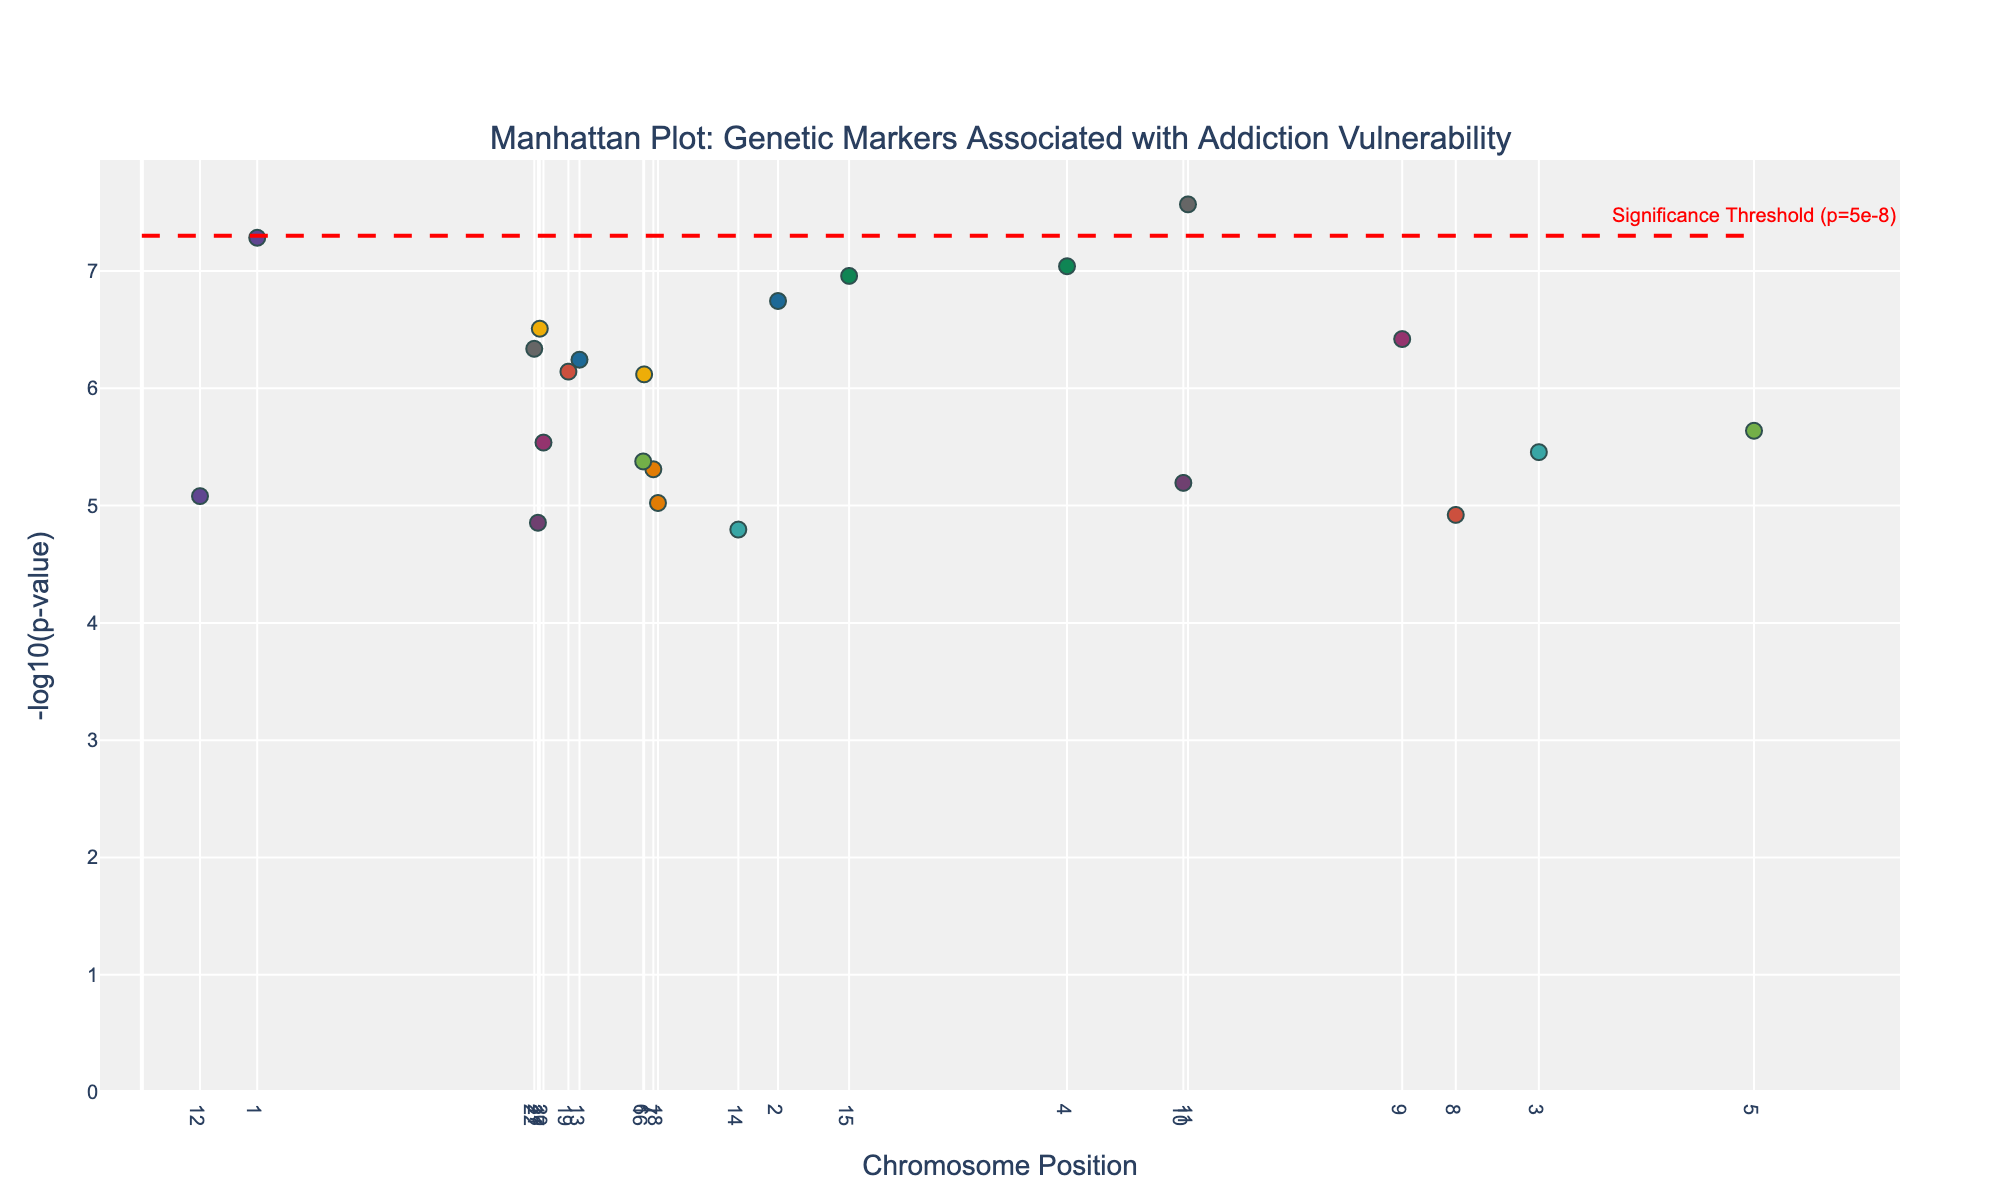What is the title of the plot? The title of the plot is displayed at the top and is meant to summarize the visualized data. The title provides context for the viewer to understand what the plot represents.
Answer: Manhattan Plot: Genetic Markers Associated with Addiction Vulnerability How many chromosomes are represented in the plot? The plot includes data points from different chromosomes. You can count the unique labels or tick marks on the x-axis to identify the number of chromosomes.
Answer: 22 What is the y-axis measuring? The y-axis represents the -log10(p-value) of genetic markers. This transformation makes it easier to see smaller p-values, which are more significant.
Answer: -log10(p-value) Which genetic marker has the most significant association with addiction vulnerability? The most significant association will have the highest -log10(p-value) value, which means the p-value is the smallest. Look for the highest point on the plot.
Answer: OPRM1 How can you determine the significance threshold on the plot? The significance threshold is indicated by a horizontal line across the plot. This line is marked with an annotation to highlight its significance.
Answer: A horizontal red dashed line labeled "Significance Threshold (p=5e-8)" Which chromosome has the most genetic markers that are above the significance threshold? Count the number of points above the significance threshold line for each chromosome. The chromosome with the most points above the line has the most significant markers.
Answer: Chromosome 11 What is the range of -log10(p-value) observed in this plot? To find the range, identify the minimum and maximum values on the y-axis. Subtract the minimum from the maximum to get the range.
Answer: The range starts from around 4.92 to 7.28 Which chromosome shows the marker with the highest p-value? The marker with the highest p-value will have the lowest -log10(p-value). Identify the lowest point on the plot and note its chromosome.
Answer: Chromosome 21 How many genetic markers are above the significance threshold? Count the number of points that are above the red dashed horizontal line, which indicates the significance threshold on the plot.
Answer: 5 Which gene located on chromosome 15 has a significant association with addiction vulnerability? Locate the chromosome 15 section on the x-axis. Identify the gene with a data point above the significance threshold in that section.
Answer: CHRNA5 